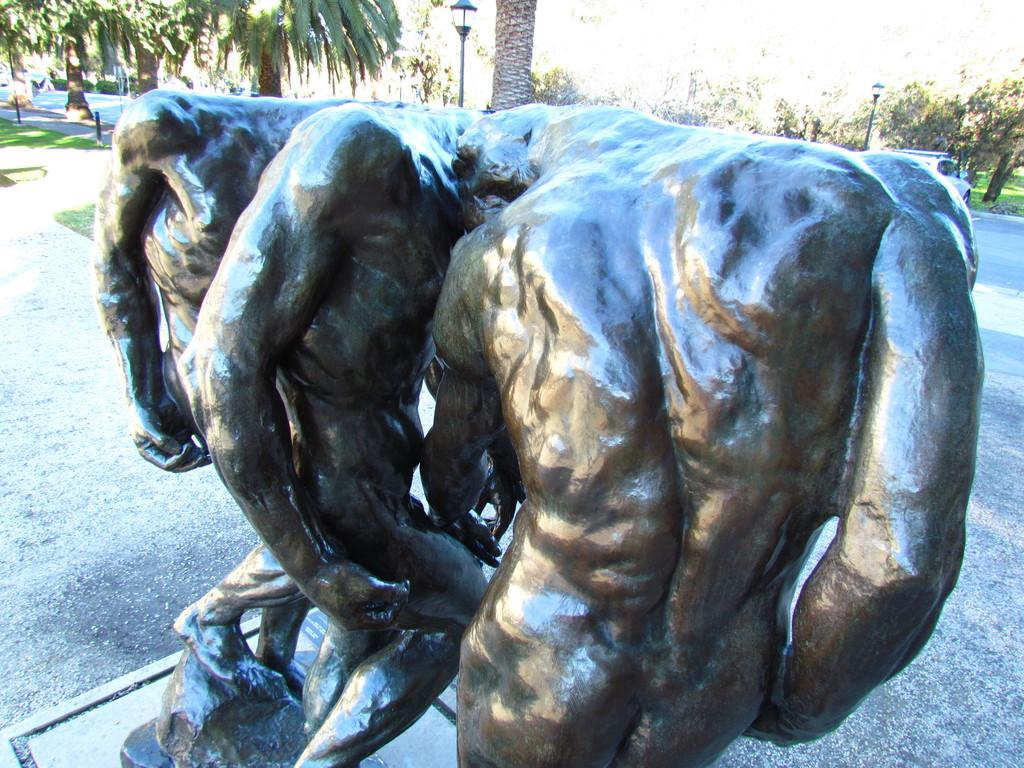What is the main subject in the image? There is a statue in the image. What else can be seen on the road in the image? There is a vehicle on the road in the image. What type of structures are present in the image? There are poles and light poles in the image. What type of vegetation is visible in the image? There is grass visible in the image. What can be seen in the background of the image? There are trees in the background of the image. What type of cheese is being used to hold the statue in place in the image? There is no cheese present in the image, and the statue is not being held in place by any cheese. 